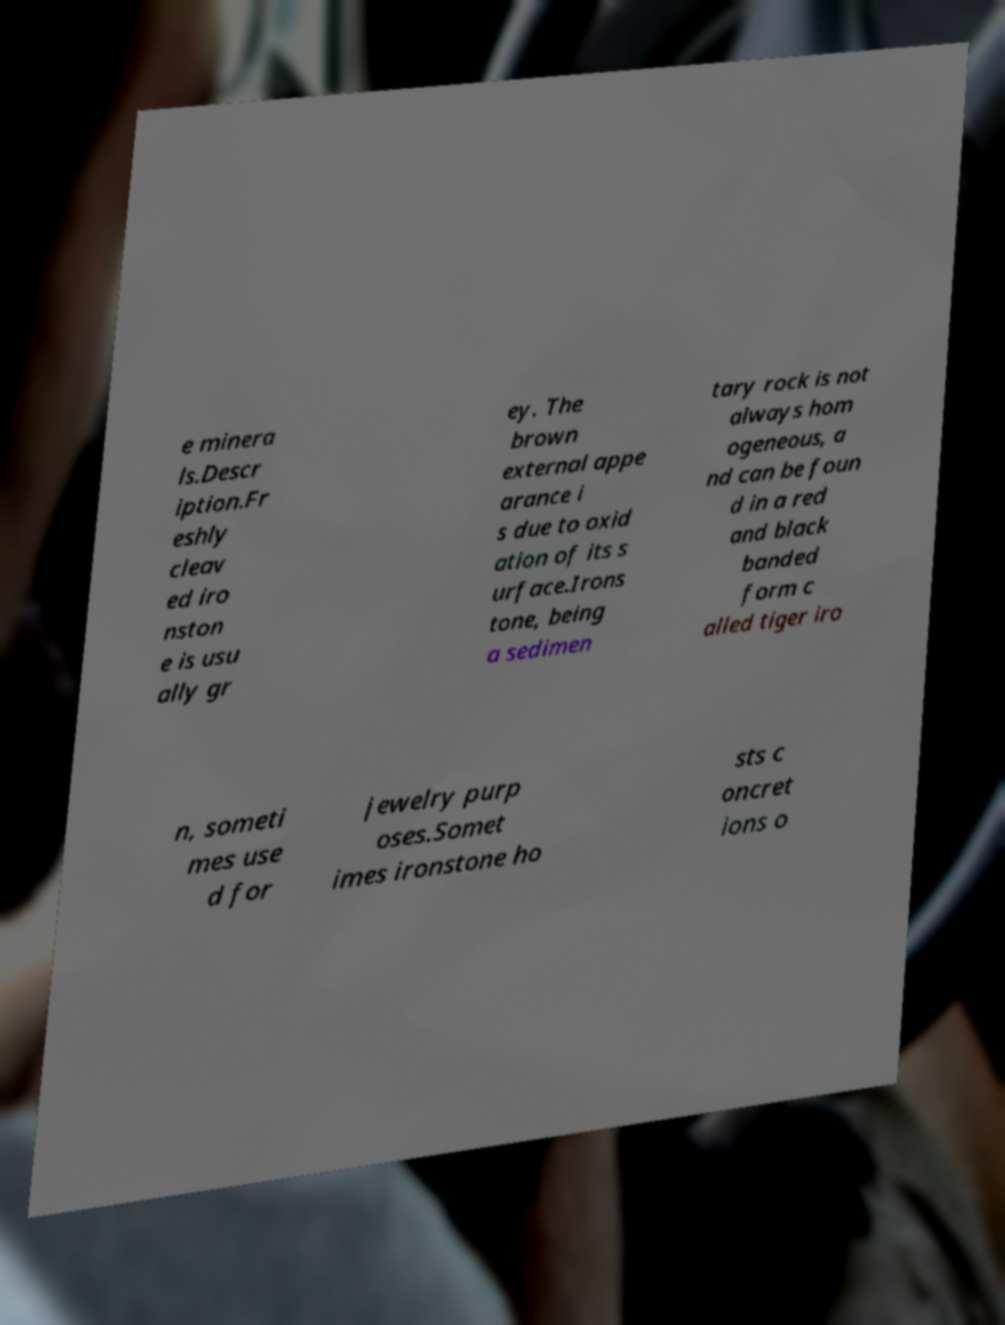I need the written content from this picture converted into text. Can you do that? e minera ls.Descr iption.Fr eshly cleav ed iro nston e is usu ally gr ey. The brown external appe arance i s due to oxid ation of its s urface.Irons tone, being a sedimen tary rock is not always hom ogeneous, a nd can be foun d in a red and black banded form c alled tiger iro n, someti mes use d for jewelry purp oses.Somet imes ironstone ho sts c oncret ions o 